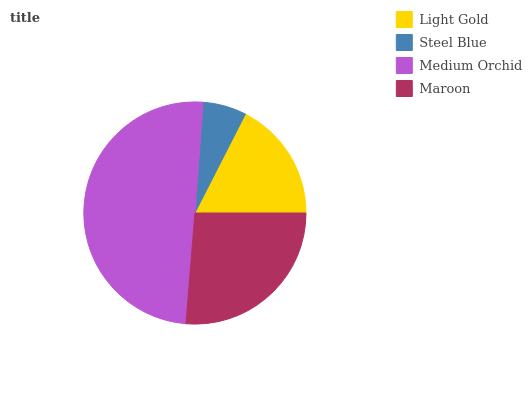Is Steel Blue the minimum?
Answer yes or no. Yes. Is Medium Orchid the maximum?
Answer yes or no. Yes. Is Medium Orchid the minimum?
Answer yes or no. No. Is Steel Blue the maximum?
Answer yes or no. No. Is Medium Orchid greater than Steel Blue?
Answer yes or no. Yes. Is Steel Blue less than Medium Orchid?
Answer yes or no. Yes. Is Steel Blue greater than Medium Orchid?
Answer yes or no. No. Is Medium Orchid less than Steel Blue?
Answer yes or no. No. Is Maroon the high median?
Answer yes or no. Yes. Is Light Gold the low median?
Answer yes or no. Yes. Is Medium Orchid the high median?
Answer yes or no. No. Is Medium Orchid the low median?
Answer yes or no. No. 